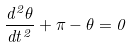<formula> <loc_0><loc_0><loc_500><loc_500>\frac { d ^ { 2 } \theta } { d t ^ { 2 } } + \pi - \theta = 0</formula> 